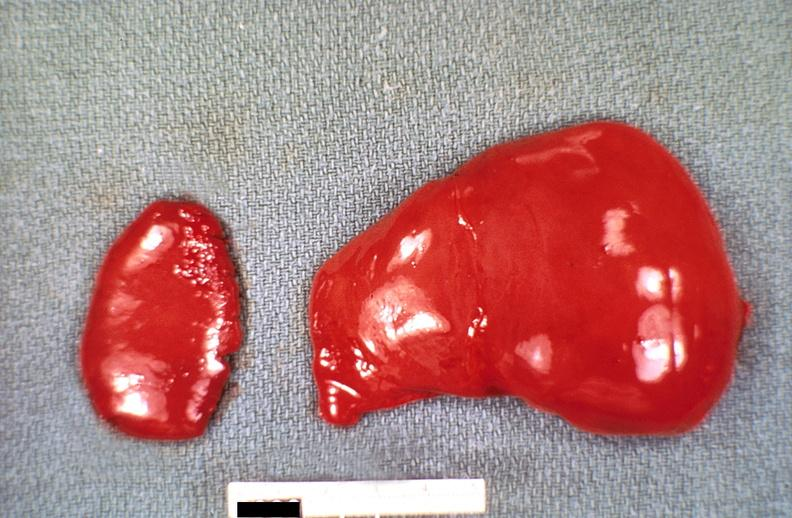s hepatobiliary present?
Answer the question using a single word or phrase. Yes 